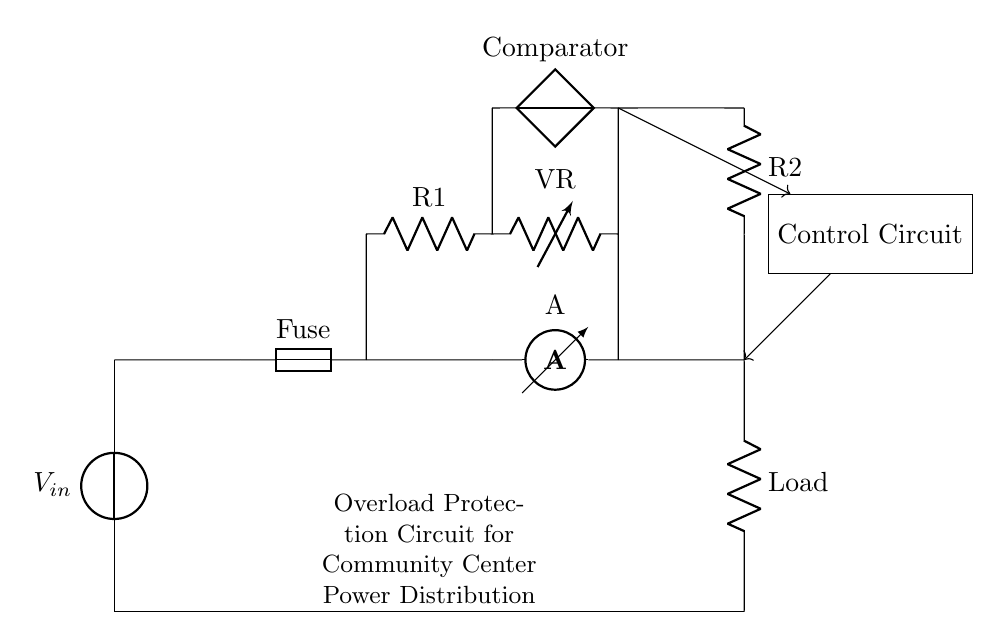What is the function of the fuse in this circuit? The fuse provides overload protection by breaking the circuit if the current exceeds a specified limit, preventing potential damage to the components.
Answer: Overload protection What does the ammeter measure in this circuit? The ammeter measures the current flowing through the circuit, allowing for monitoring of the load and detection of overload conditions.
Answer: Current What component is used to control the circuit? The control circuit consists of a comparator that helps in determining when the current is too high and triggers the protective measures.
Answer: Comparator What is the purpose of resistors R1 and R2? Resistors R1 and R2 are used in the control circuit to set thresholds for operation and adjust the current flow, helping in the overload detection mechanism.
Answer: Threshold setting How does the control circuit respond to an overload? The control circuit receives signals from the comparator and activates a mechanism to disconnect the load from the power source to prevent damage.
Answer: Disconnects the load What happens to the circuit when the current exceeds a certain limit? When the current exceeds the limit, the fuse will blow, breaking the circuit and stopping the power to prevent hazards.
Answer: Fuse blows Which component indicates the state of an overload condition? The ammeter provides a visual indication of the current, and if the needle moves beyond the safe range, it signifies an overload condition.
Answer: Ammeter 